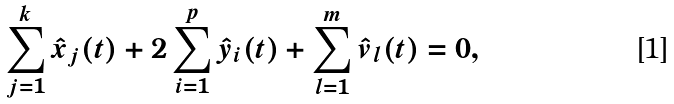Convert formula to latex. <formula><loc_0><loc_0><loc_500><loc_500>\sum _ { j = 1 } ^ { k } \hat { x } _ { j } ( t ) + 2 \sum _ { i = 1 } ^ { p } \hat { y } _ { i } ( t ) + \sum _ { l = 1 } ^ { m } \hat { v } _ { l } ( t ) = 0 ,</formula> 